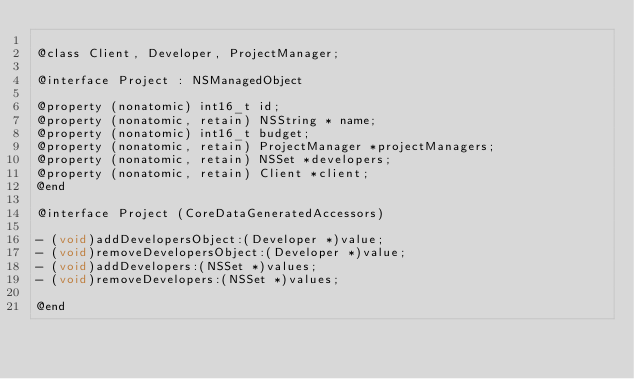<code> <loc_0><loc_0><loc_500><loc_500><_C_>
@class Client, Developer, ProjectManager;

@interface Project : NSManagedObject

@property (nonatomic) int16_t id;
@property (nonatomic, retain) NSString * name;
@property (nonatomic) int16_t budget;
@property (nonatomic, retain) ProjectManager *projectManagers;
@property (nonatomic, retain) NSSet *developers;
@property (nonatomic, retain) Client *client;
@end

@interface Project (CoreDataGeneratedAccessors)

- (void)addDevelopersObject:(Developer *)value;
- (void)removeDevelopersObject:(Developer *)value;
- (void)addDevelopers:(NSSet *)values;
- (void)removeDevelopers:(NSSet *)values;

@end
</code> 